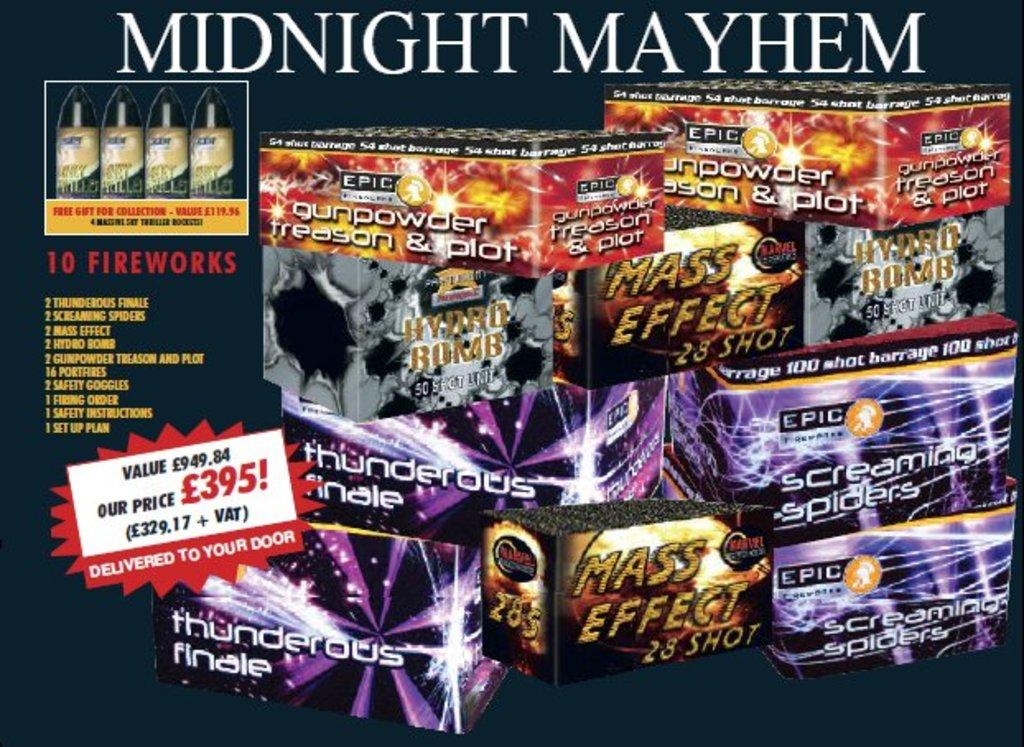<image>
Share a concise interpretation of the image provided. Boxes full of fireworks from the company Mindnight Mayhem. 